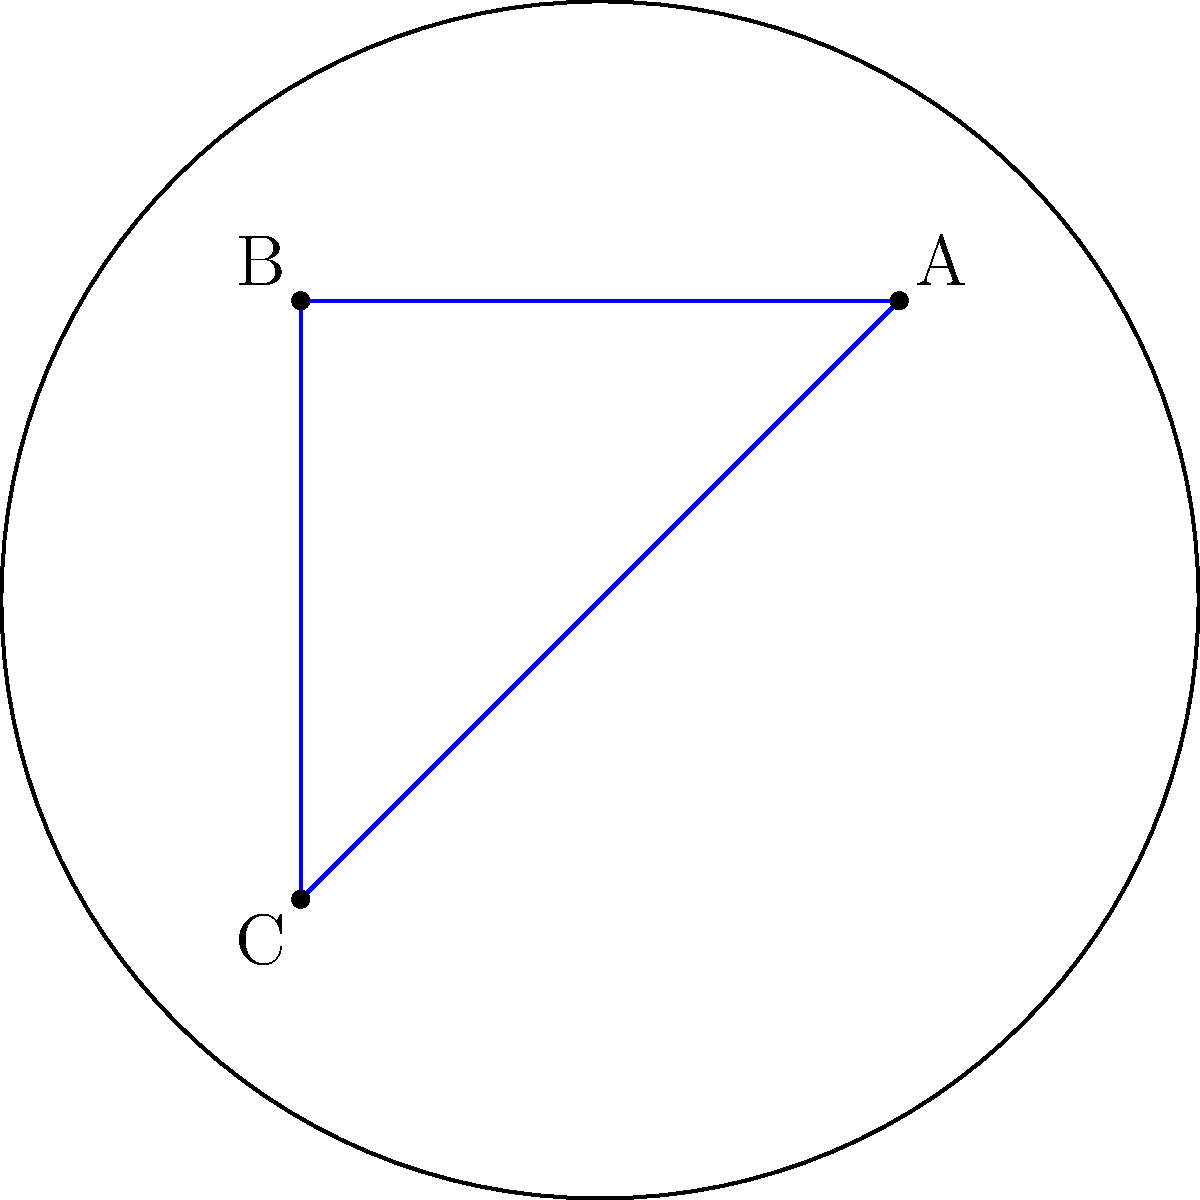In the Poincaré disk model of hyperbolic geometry shown above, we have a triangle ABC and a circular arc passing through its vertices. Which statement is true about this configuration? To answer this question, let's analyze the properties of the Poincaré disk model and the given configuration:

1. The Poincaré disk model represents the entire hyperbolic plane as the interior of a circle, where the boundary of the circle represents points at infinity.

2. In this model, straight lines in hyperbolic geometry are represented by either:
   a) Diameters of the disk
   b) Circular arcs that are perpendicular to the boundary circle

3. In the given diagram:
   - The blue lines forming the triangle ABC are straight lines in hyperbolic geometry.
   - The red circular arc passing through A, B, and C is also a straight line in hyperbolic geometry.

4. In Euclidean geometry, we know that three points determine a unique circle. However, in hyperbolic geometry (as represented in the Poincaré disk model), this is not always the case.

5. The fact that there exists a circular arc (red line) passing through all three vertices of the triangle indicates that these points are collinear in hyperbolic geometry.

6. In hyperbolic geometry, when three points are collinear, any "straight line" (represented as a circular arc in the Poincaré model) passing through two of these points must also pass through the third.

Therefore, the key insight is that points A, B, and C are collinear in hyperbolic geometry, despite appearing to form a triangle in the Euclidean sense within the Poincaré disk representation.
Answer: Points A, B, and C are collinear in hyperbolic geometry. 